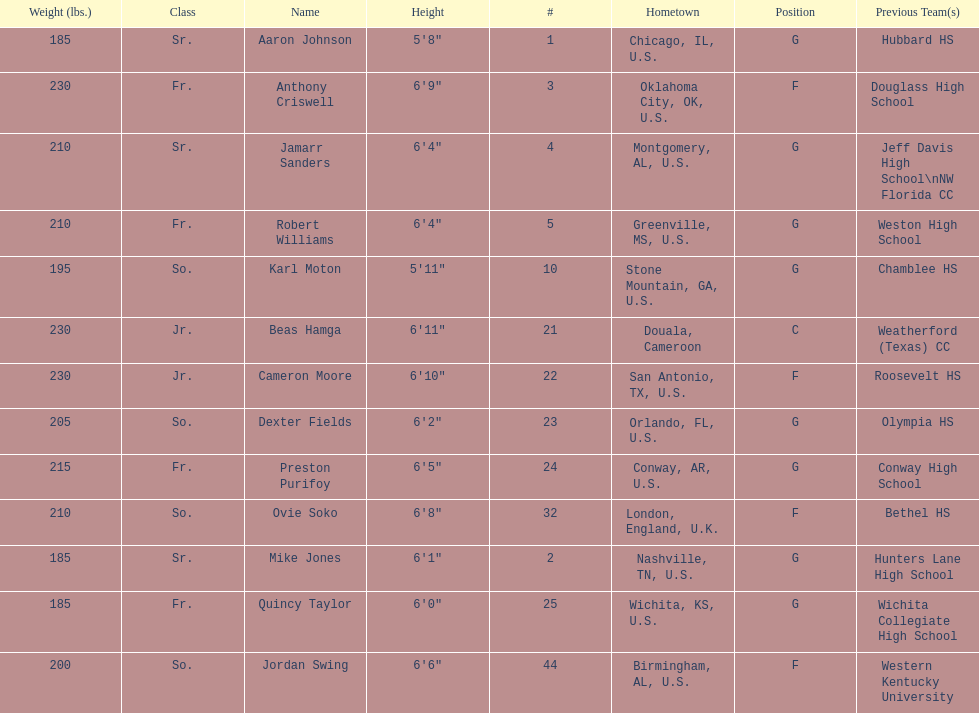Tell me the number of juniors on the team. 2. 